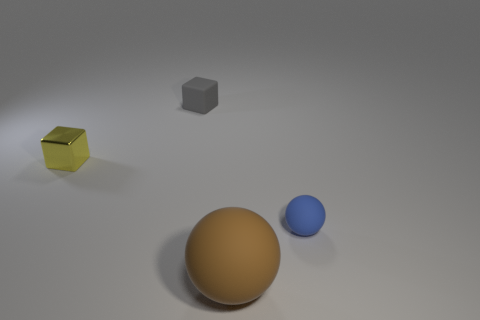Are there more large matte spheres that are on the right side of the big brown matte object than big purple objects?
Make the answer very short. No. There is a block that is in front of the small gray rubber object; how many gray things are on the left side of it?
Offer a very short reply. 0. What shape is the brown rubber object that is in front of the yellow shiny cube on the left side of the thing in front of the small blue thing?
Offer a very short reply. Sphere. The brown matte ball is what size?
Your answer should be very brief. Large. Is there a yellow sphere made of the same material as the brown object?
Offer a terse response. No. There is another thing that is the same shape as the brown object; what size is it?
Offer a very short reply. Small. Is the number of brown balls that are behind the blue ball the same as the number of yellow objects?
Offer a very short reply. No. There is a tiny thing that is in front of the metallic block; is it the same shape as the tiny yellow metallic object?
Give a very brief answer. No. The blue object has what shape?
Offer a terse response. Sphere. There is a block left of the object that is behind the tiny cube left of the small gray cube; what is its material?
Keep it short and to the point. Metal. 